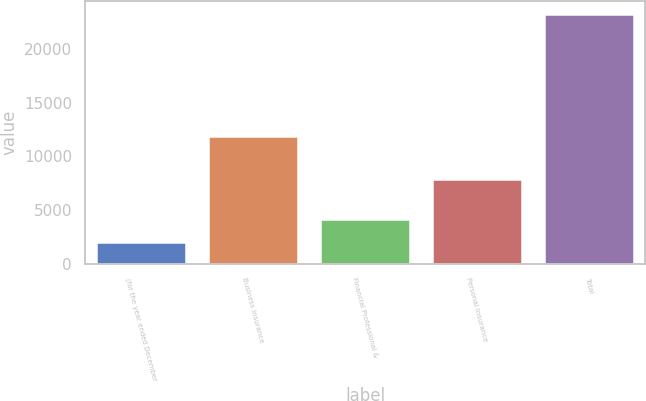Convert chart. <chart><loc_0><loc_0><loc_500><loc_500><bar_chart><fcel>(for the year ended December<fcel>Business Insurance<fcel>Financial Professional &<fcel>Personal Insurance<fcel>Total<nl><fcel>2010<fcel>11891<fcel>4139.2<fcel>7877<fcel>23302<nl></chart> 